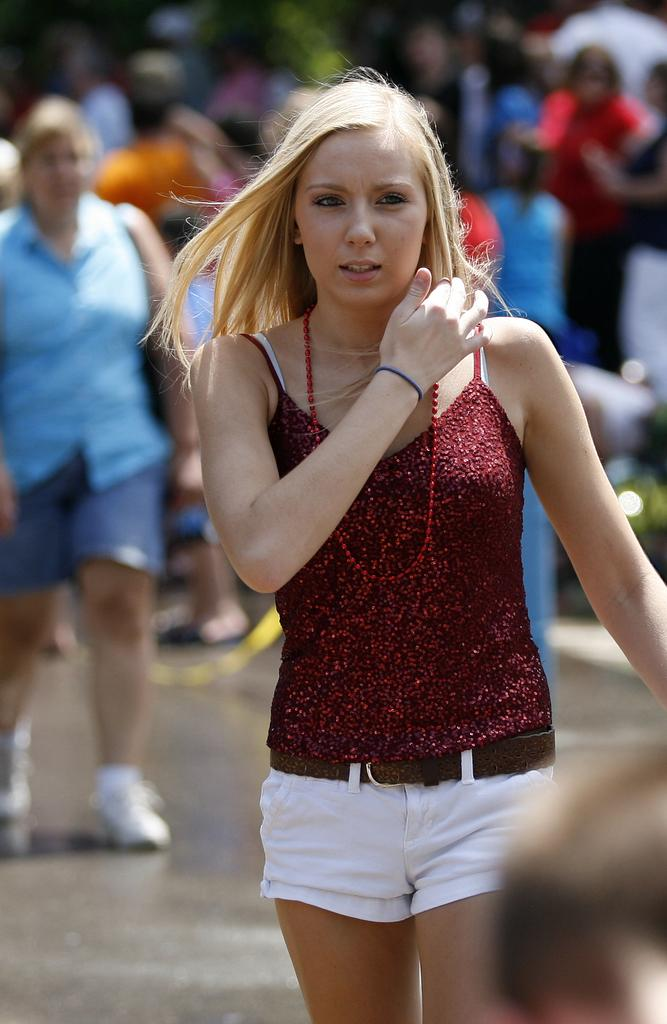How many people are present in the image? There are many people in the image. What can be observed about the background of the image? The background of the image is blurred. Can you describe the lady's accessory in the image? A lady is wearing a handbag on her shoulder. What type of kite is the lady flying in the image? There is no kite present in the image. How does the lady manage to get the attention of the crowd in the image? The image does not provide information about the lady's actions or the crowd's reactions, so it cannot be determined how she gets their attention. 